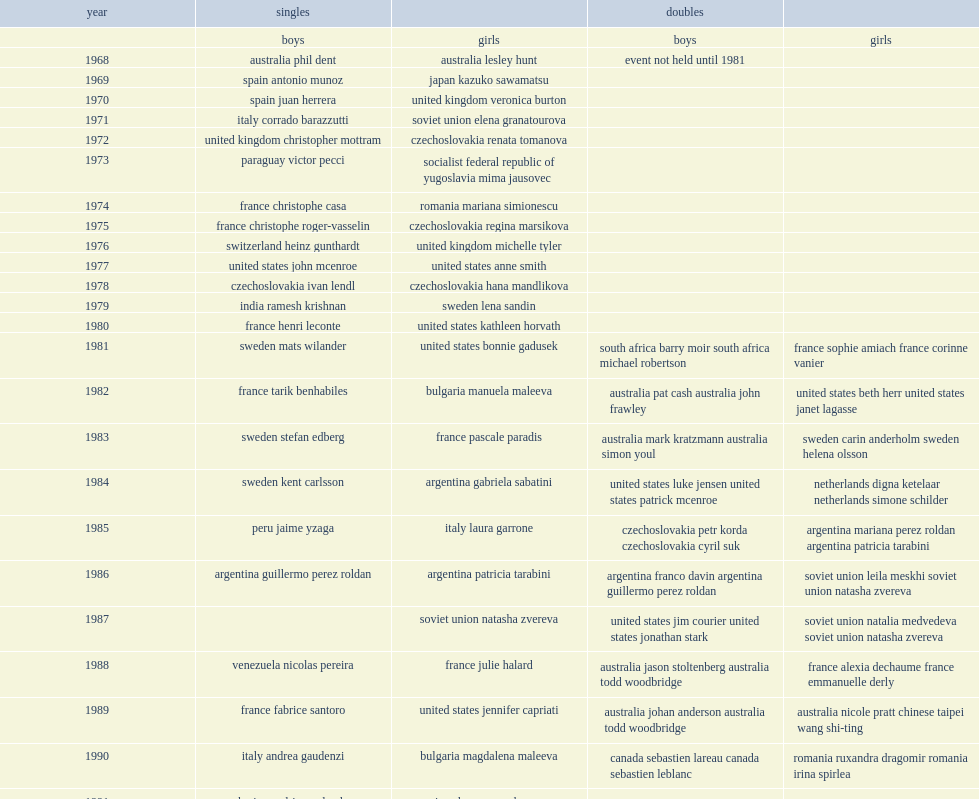Which country was michelle tyler from won the singles title at the french open girls event in 1976? United kingdom michelle tyler. 